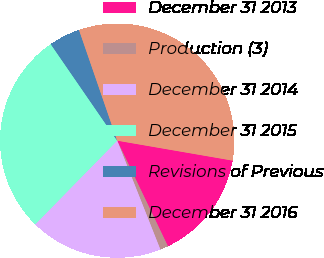Convert chart to OTSL. <chart><loc_0><loc_0><loc_500><loc_500><pie_chart><fcel>December 31 2013<fcel>Production (3)<fcel>December 31 2014<fcel>December 31 2015<fcel>Revisions of Previous<fcel>December 31 2016<nl><fcel>15.15%<fcel>1.12%<fcel>18.34%<fcel>28.07%<fcel>4.31%<fcel>33.01%<nl></chart> 